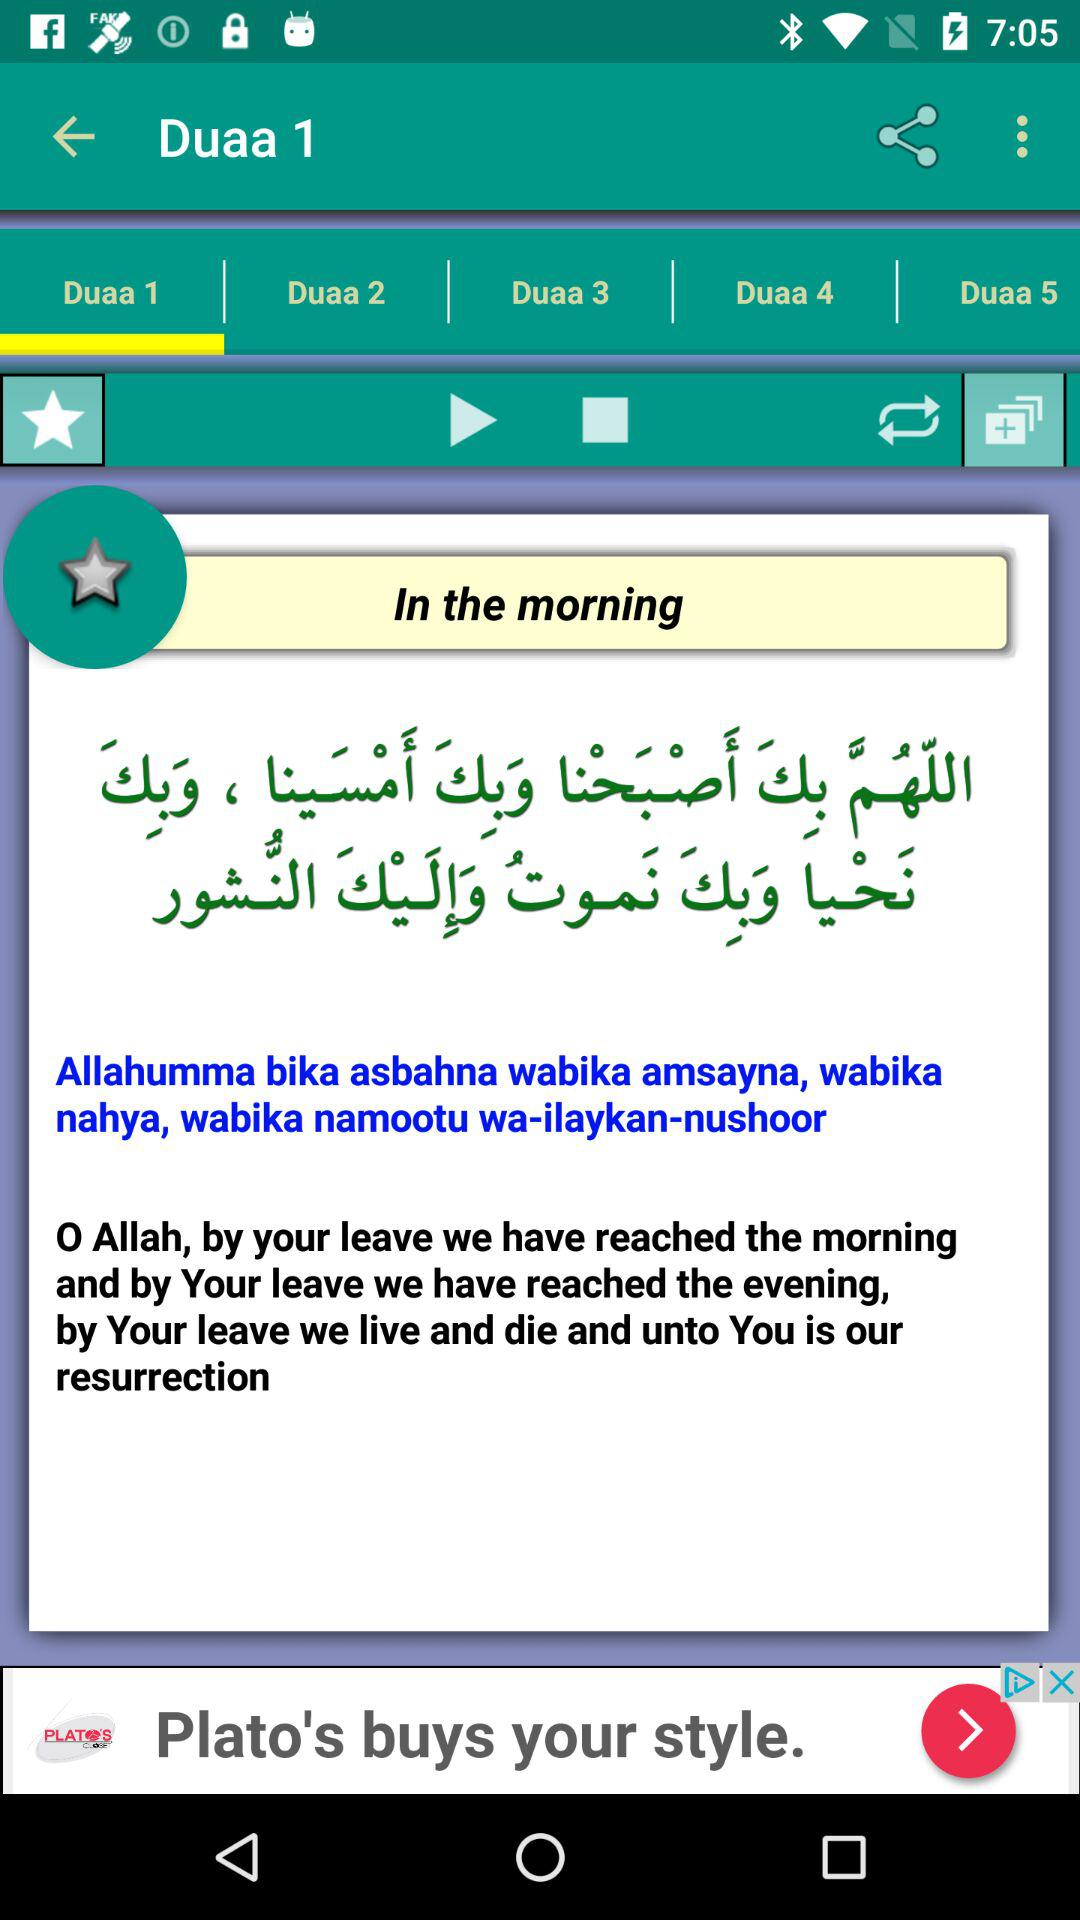Which tab is selected? The selected tab is "Duaa 1". 